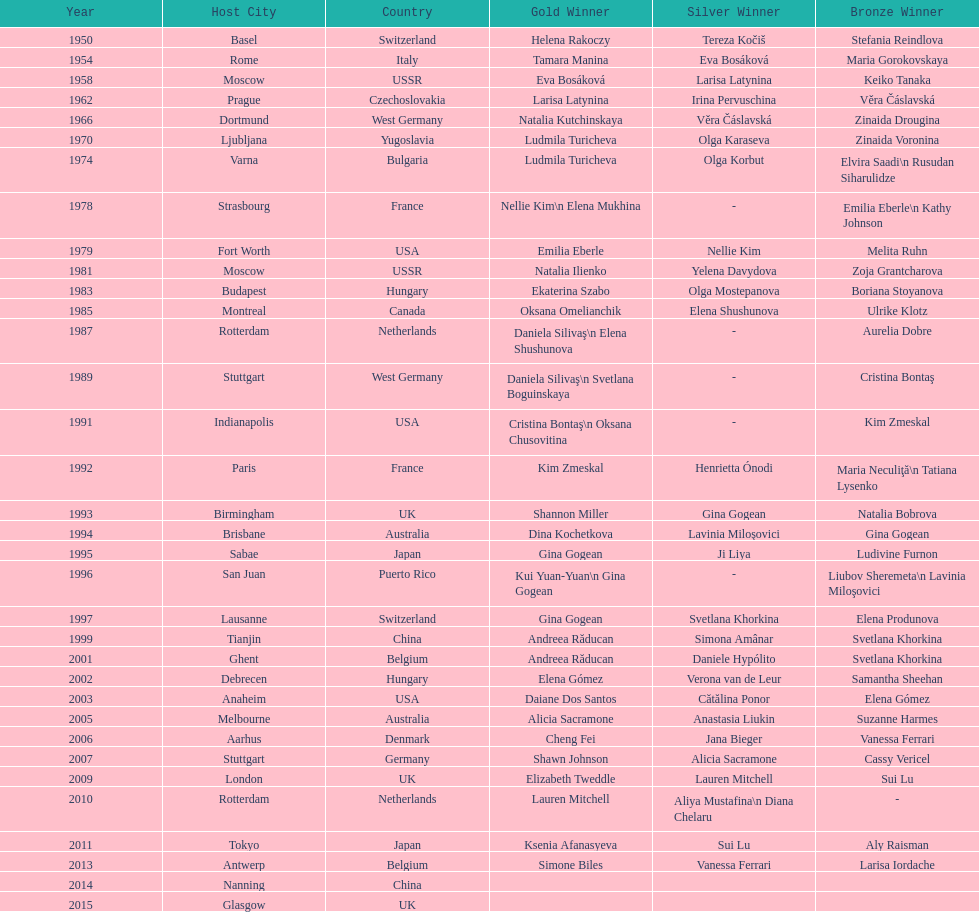Which two american rivals won consecutive floor exercise gold medals at the artistic gymnastics world championships in 1992 and 1993? Kim Zmeskal, Shannon Miller. 